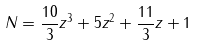<formula> <loc_0><loc_0><loc_500><loc_500>N = \frac { 1 0 } { 3 } z ^ { 3 } + 5 z ^ { 2 } + \frac { 1 1 } { 3 } z + 1</formula> 